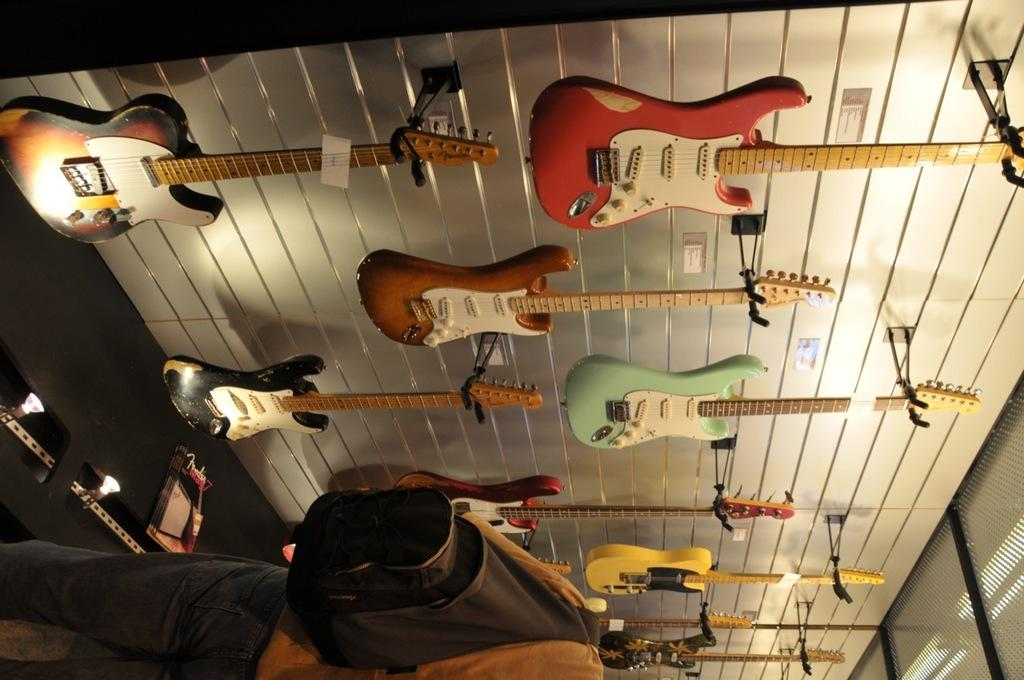What is the man in the image doing? The man is standing in the image. What is the man holding in the image? The man is holding a backpack. What can be seen on the wall in the background of the image? There are guitars on the wall in the background of the image. What degree does the man have in the image? There is no information about the man's degree in the image. 